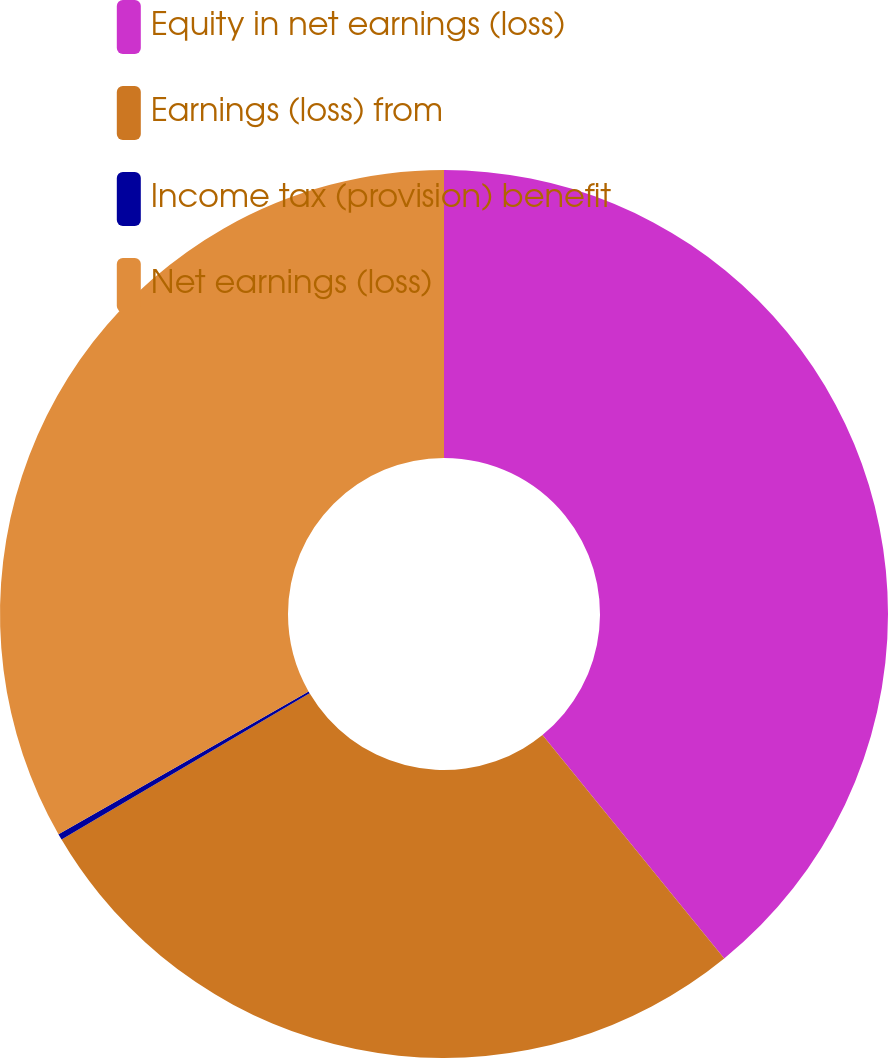Convert chart. <chart><loc_0><loc_0><loc_500><loc_500><pie_chart><fcel>Equity in net earnings (loss)<fcel>Earnings (loss) from<fcel>Income tax (provision) benefit<fcel>Net earnings (loss)<nl><fcel>39.13%<fcel>27.39%<fcel>0.22%<fcel>33.26%<nl></chart> 